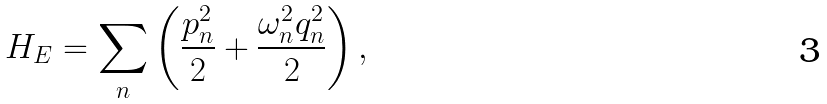<formula> <loc_0><loc_0><loc_500><loc_500>H _ { E } = \sum _ { n } \left ( \frac { p _ { n } ^ { 2 } } { 2 } + \frac { \omega _ { n } ^ { 2 } q _ { n } ^ { 2 } } { 2 } \right ) ,</formula> 